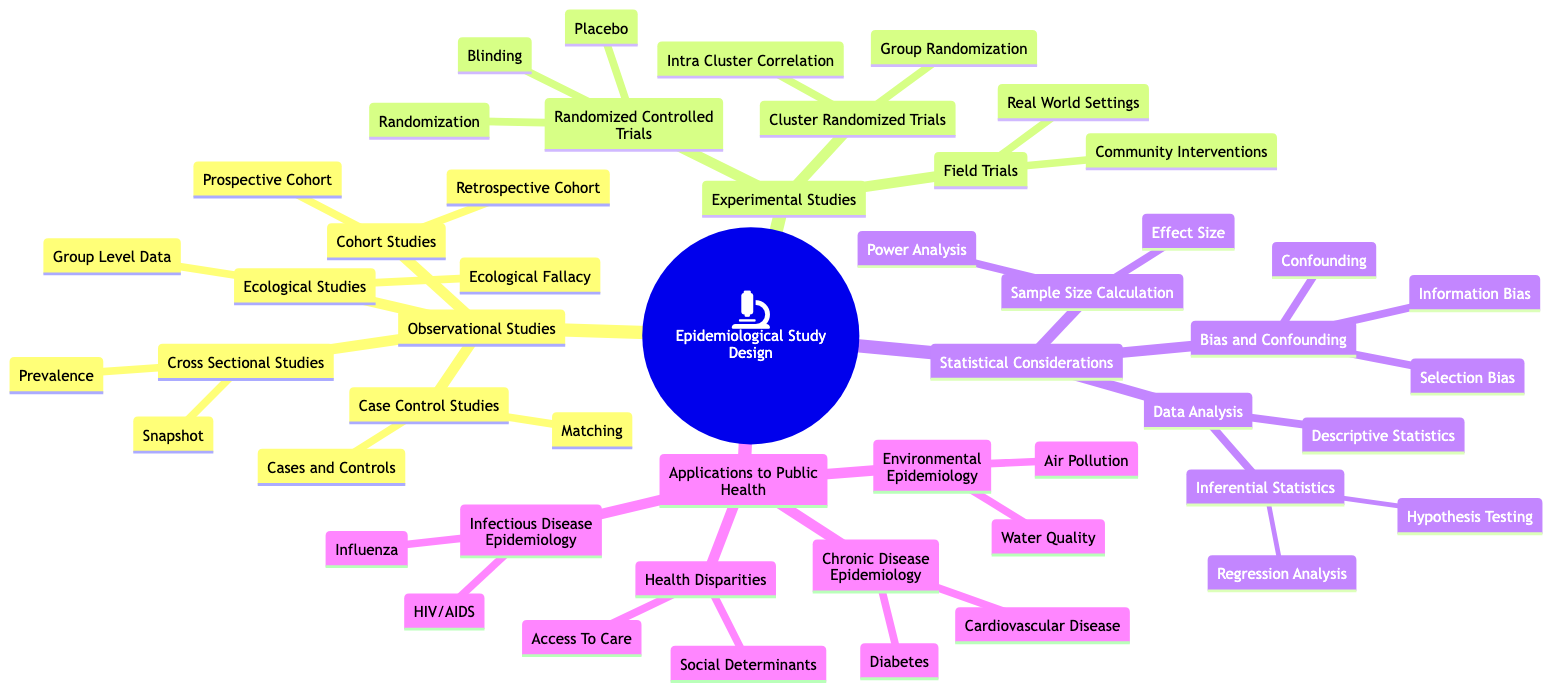What are the two types of cohort studies? The diagram lists "Prospective Cohort" and "Retrospective Cohort" under "Cohort Studies" in the "Observational Studies" section.
Answer: Prospective Cohort, Retrospective Cohort What is the main purpose of matching in case control studies? In the diagram, "Matching" is described as ensuring cases and controls are similar in key characteristics, found under "Case Control Studies".
Answer: Ensuring similarity in key characteristics What are the two types of bias mentioned in the statistical considerations? The diagram presents "Selection Bias" and "Information Bias" under "Bias and Confounding" in the "Statistical Considerations" section.
Answer: Selection Bias, Information Bias Which study design allows for random assignment? The diagram specifies that "Randomized Controlled Trials" involve random assignment under "Experimental Studies".
Answer: Randomized Controlled Trials How does ecological fallacy pose a risk in ecological studies? The diagram explains "Ecological Fallacy" as a potential misinterpretation due to attributing group-level findings to individuals, listed under "Ecological Studies".
Answer: Misinterpretation of group-level findings What type of analysis helps to determine the sample size needed? The diagram states that "Power Analysis" is used for this purpose, found under "Sample Size Calculation" in "Statistical Considerations".
Answer: Power Analysis Which two applications are studied in chronic disease epidemiology? The diagram identifies "Diabetes" and "Cardiovascular Disease" under "Chronic Disease Epidemiology" in the "Applications to Public Health" section.
Answer: Diabetes, Cardiovascular Disease How are groups randomized in cluster randomized trials? The diagram notes that group randomization is used in "Cluster Randomized Trials", found under "Experimental Studies".
Answer: Group Randomization What type of studies analyze data at a single point in time? The diagram indicates "Cross Sectional Studies" as the category that analyzes data at a single point, labeled under "Observational Studies".
Answer: Cross Sectional Studies 